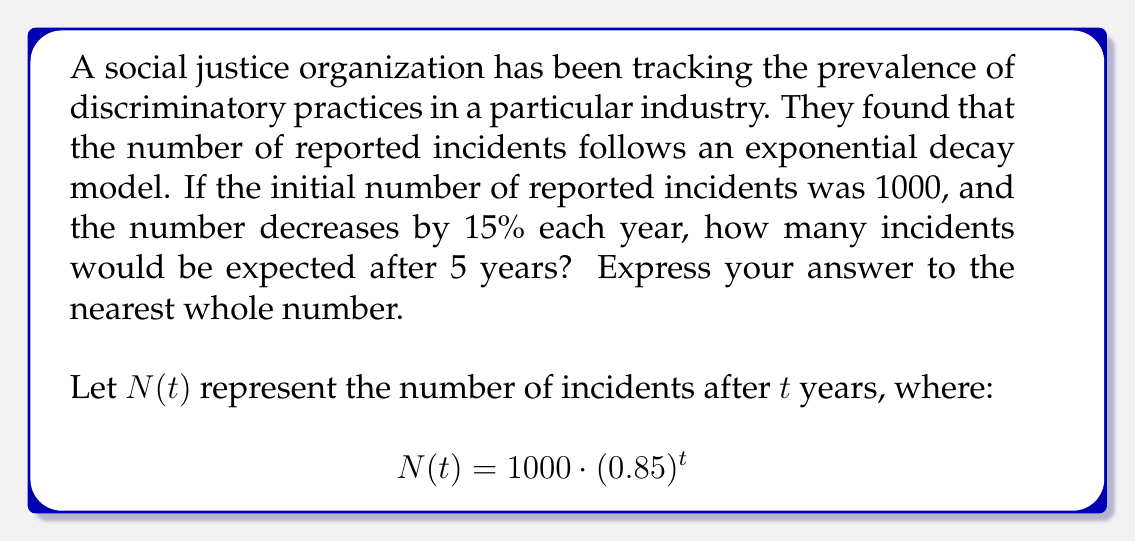Give your solution to this math problem. To solve this problem, we'll follow these steps:

1) We're given the exponential decay formula:
   $N(t) = 1000 \cdot (0.85)^t$

2) We need to find $N(5)$, as we're asked about the number of incidents after 5 years:
   $N(5) = 1000 \cdot (0.85)^5$

3) Let's calculate this step-by-step:
   $N(5) = 1000 \cdot (0.85)^5$
   $= 1000 \cdot 0.4437053462$
   $= 443.7053462$

4) Rounding to the nearest whole number:
   $443.7053462 \approx 444$

Thus, after 5 years, we would expect approximately 444 incidents.
Answer: 444 